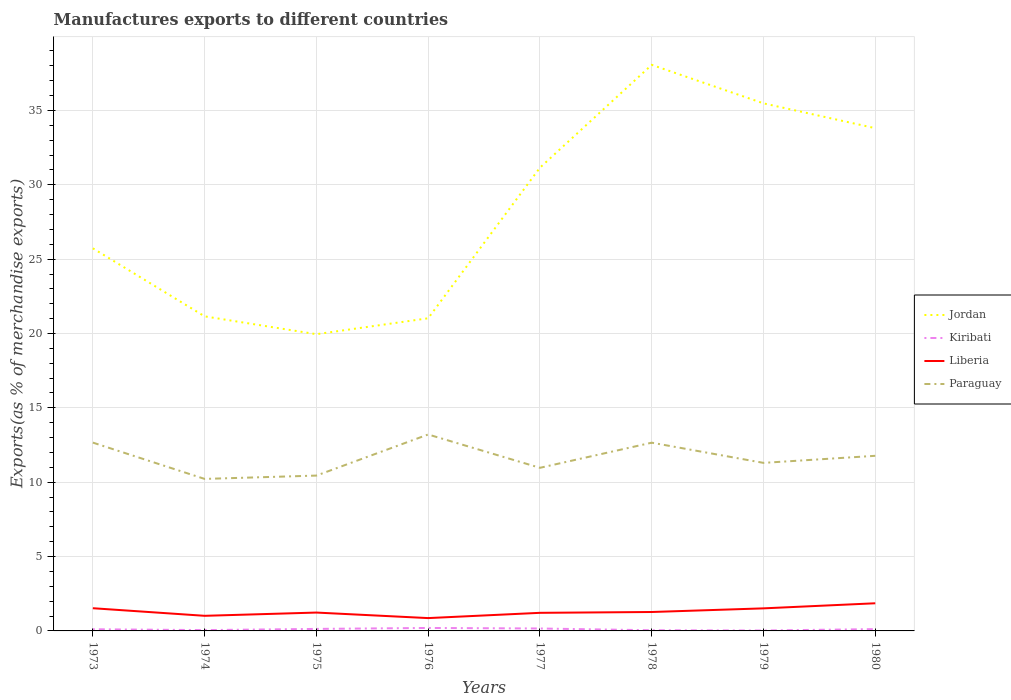How many different coloured lines are there?
Your response must be concise. 4. Across all years, what is the maximum percentage of exports to different countries in Paraguay?
Make the answer very short. 10.22. In which year was the percentage of exports to different countries in Kiribati maximum?
Offer a very short reply. 1979. What is the total percentage of exports to different countries in Jordan in the graph?
Provide a short and direct response. -11.2. What is the difference between the highest and the second highest percentage of exports to different countries in Paraguay?
Offer a terse response. 2.99. Is the percentage of exports to different countries in Kiribati strictly greater than the percentage of exports to different countries in Jordan over the years?
Your response must be concise. Yes. What is the difference between two consecutive major ticks on the Y-axis?
Provide a succinct answer. 5. How many legend labels are there?
Provide a succinct answer. 4. How are the legend labels stacked?
Give a very brief answer. Vertical. What is the title of the graph?
Provide a succinct answer. Manufactures exports to different countries. What is the label or title of the Y-axis?
Your response must be concise. Exports(as % of merchandise exports). What is the Exports(as % of merchandise exports) of Jordan in 1973?
Give a very brief answer. 25.73. What is the Exports(as % of merchandise exports) of Kiribati in 1973?
Your answer should be very brief. 0.11. What is the Exports(as % of merchandise exports) in Liberia in 1973?
Give a very brief answer. 1.53. What is the Exports(as % of merchandise exports) in Paraguay in 1973?
Your answer should be compact. 12.66. What is the Exports(as % of merchandise exports) in Jordan in 1974?
Ensure brevity in your answer.  21.15. What is the Exports(as % of merchandise exports) in Kiribati in 1974?
Ensure brevity in your answer.  0.06. What is the Exports(as % of merchandise exports) in Liberia in 1974?
Ensure brevity in your answer.  1.02. What is the Exports(as % of merchandise exports) of Paraguay in 1974?
Your response must be concise. 10.22. What is the Exports(as % of merchandise exports) of Jordan in 1975?
Your answer should be compact. 19.95. What is the Exports(as % of merchandise exports) in Kiribati in 1975?
Offer a very short reply. 0.14. What is the Exports(as % of merchandise exports) in Liberia in 1975?
Give a very brief answer. 1.23. What is the Exports(as % of merchandise exports) in Paraguay in 1975?
Give a very brief answer. 10.45. What is the Exports(as % of merchandise exports) in Jordan in 1976?
Keep it short and to the point. 21.02. What is the Exports(as % of merchandise exports) in Kiribati in 1976?
Provide a short and direct response. 0.2. What is the Exports(as % of merchandise exports) of Liberia in 1976?
Your response must be concise. 0.86. What is the Exports(as % of merchandise exports) of Paraguay in 1976?
Your answer should be compact. 13.21. What is the Exports(as % of merchandise exports) in Jordan in 1977?
Your answer should be very brief. 31.15. What is the Exports(as % of merchandise exports) of Kiribati in 1977?
Provide a short and direct response. 0.16. What is the Exports(as % of merchandise exports) in Liberia in 1977?
Keep it short and to the point. 1.22. What is the Exports(as % of merchandise exports) in Paraguay in 1977?
Your answer should be compact. 10.97. What is the Exports(as % of merchandise exports) of Jordan in 1978?
Give a very brief answer. 38.06. What is the Exports(as % of merchandise exports) in Kiribati in 1978?
Make the answer very short. 0.05. What is the Exports(as % of merchandise exports) in Liberia in 1978?
Make the answer very short. 1.27. What is the Exports(as % of merchandise exports) in Paraguay in 1978?
Make the answer very short. 12.66. What is the Exports(as % of merchandise exports) in Jordan in 1979?
Your answer should be compact. 35.47. What is the Exports(as % of merchandise exports) in Kiribati in 1979?
Your answer should be very brief. 0.03. What is the Exports(as % of merchandise exports) of Liberia in 1979?
Offer a very short reply. 1.52. What is the Exports(as % of merchandise exports) of Paraguay in 1979?
Give a very brief answer. 11.3. What is the Exports(as % of merchandise exports) in Jordan in 1980?
Your answer should be compact. 33.81. What is the Exports(as % of merchandise exports) of Kiribati in 1980?
Your answer should be very brief. 0.12. What is the Exports(as % of merchandise exports) of Liberia in 1980?
Your answer should be compact. 1.86. What is the Exports(as % of merchandise exports) of Paraguay in 1980?
Provide a short and direct response. 11.77. Across all years, what is the maximum Exports(as % of merchandise exports) of Jordan?
Your answer should be compact. 38.06. Across all years, what is the maximum Exports(as % of merchandise exports) of Kiribati?
Provide a succinct answer. 0.2. Across all years, what is the maximum Exports(as % of merchandise exports) of Liberia?
Your answer should be compact. 1.86. Across all years, what is the maximum Exports(as % of merchandise exports) of Paraguay?
Give a very brief answer. 13.21. Across all years, what is the minimum Exports(as % of merchandise exports) in Jordan?
Your response must be concise. 19.95. Across all years, what is the minimum Exports(as % of merchandise exports) in Kiribati?
Give a very brief answer. 0.03. Across all years, what is the minimum Exports(as % of merchandise exports) of Liberia?
Make the answer very short. 0.86. Across all years, what is the minimum Exports(as % of merchandise exports) in Paraguay?
Your answer should be compact. 10.22. What is the total Exports(as % of merchandise exports) of Jordan in the graph?
Provide a succinct answer. 226.35. What is the total Exports(as % of merchandise exports) in Kiribati in the graph?
Provide a succinct answer. 0.86. What is the total Exports(as % of merchandise exports) of Liberia in the graph?
Give a very brief answer. 10.51. What is the total Exports(as % of merchandise exports) in Paraguay in the graph?
Offer a very short reply. 93.24. What is the difference between the Exports(as % of merchandise exports) of Jordan in 1973 and that in 1974?
Your answer should be very brief. 4.58. What is the difference between the Exports(as % of merchandise exports) in Kiribati in 1973 and that in 1974?
Make the answer very short. 0.06. What is the difference between the Exports(as % of merchandise exports) in Liberia in 1973 and that in 1974?
Your answer should be very brief. 0.51. What is the difference between the Exports(as % of merchandise exports) in Paraguay in 1973 and that in 1974?
Your response must be concise. 2.44. What is the difference between the Exports(as % of merchandise exports) in Jordan in 1973 and that in 1975?
Give a very brief answer. 5.78. What is the difference between the Exports(as % of merchandise exports) in Kiribati in 1973 and that in 1975?
Ensure brevity in your answer.  -0.02. What is the difference between the Exports(as % of merchandise exports) of Liberia in 1973 and that in 1975?
Provide a short and direct response. 0.29. What is the difference between the Exports(as % of merchandise exports) of Paraguay in 1973 and that in 1975?
Offer a very short reply. 2.22. What is the difference between the Exports(as % of merchandise exports) in Jordan in 1973 and that in 1976?
Keep it short and to the point. 4.71. What is the difference between the Exports(as % of merchandise exports) of Kiribati in 1973 and that in 1976?
Offer a terse response. -0.09. What is the difference between the Exports(as % of merchandise exports) in Liberia in 1973 and that in 1976?
Provide a short and direct response. 0.66. What is the difference between the Exports(as % of merchandise exports) in Paraguay in 1973 and that in 1976?
Give a very brief answer. -0.55. What is the difference between the Exports(as % of merchandise exports) in Jordan in 1973 and that in 1977?
Provide a short and direct response. -5.42. What is the difference between the Exports(as % of merchandise exports) in Kiribati in 1973 and that in 1977?
Ensure brevity in your answer.  -0.05. What is the difference between the Exports(as % of merchandise exports) of Liberia in 1973 and that in 1977?
Your response must be concise. 0.31. What is the difference between the Exports(as % of merchandise exports) in Paraguay in 1973 and that in 1977?
Offer a terse response. 1.7. What is the difference between the Exports(as % of merchandise exports) in Jordan in 1973 and that in 1978?
Your response must be concise. -12.34. What is the difference between the Exports(as % of merchandise exports) in Kiribati in 1973 and that in 1978?
Offer a very short reply. 0.07. What is the difference between the Exports(as % of merchandise exports) of Liberia in 1973 and that in 1978?
Keep it short and to the point. 0.26. What is the difference between the Exports(as % of merchandise exports) in Paraguay in 1973 and that in 1978?
Your answer should be very brief. 0.01. What is the difference between the Exports(as % of merchandise exports) in Jordan in 1973 and that in 1979?
Ensure brevity in your answer.  -9.75. What is the difference between the Exports(as % of merchandise exports) in Kiribati in 1973 and that in 1979?
Give a very brief answer. 0.08. What is the difference between the Exports(as % of merchandise exports) of Liberia in 1973 and that in 1979?
Your response must be concise. 0.01. What is the difference between the Exports(as % of merchandise exports) of Paraguay in 1973 and that in 1979?
Provide a short and direct response. 1.36. What is the difference between the Exports(as % of merchandise exports) of Jordan in 1973 and that in 1980?
Provide a succinct answer. -8.08. What is the difference between the Exports(as % of merchandise exports) of Kiribati in 1973 and that in 1980?
Your answer should be very brief. -0.01. What is the difference between the Exports(as % of merchandise exports) of Liberia in 1973 and that in 1980?
Give a very brief answer. -0.33. What is the difference between the Exports(as % of merchandise exports) of Paraguay in 1973 and that in 1980?
Keep it short and to the point. 0.89. What is the difference between the Exports(as % of merchandise exports) in Kiribati in 1974 and that in 1975?
Provide a short and direct response. -0.08. What is the difference between the Exports(as % of merchandise exports) in Liberia in 1974 and that in 1975?
Your answer should be very brief. -0.22. What is the difference between the Exports(as % of merchandise exports) of Paraguay in 1974 and that in 1975?
Keep it short and to the point. -0.22. What is the difference between the Exports(as % of merchandise exports) in Jordan in 1974 and that in 1976?
Your answer should be compact. 0.13. What is the difference between the Exports(as % of merchandise exports) in Kiribati in 1974 and that in 1976?
Give a very brief answer. -0.14. What is the difference between the Exports(as % of merchandise exports) of Liberia in 1974 and that in 1976?
Your answer should be compact. 0.15. What is the difference between the Exports(as % of merchandise exports) of Paraguay in 1974 and that in 1976?
Your answer should be compact. -2.99. What is the difference between the Exports(as % of merchandise exports) in Jordan in 1974 and that in 1977?
Offer a very short reply. -10. What is the difference between the Exports(as % of merchandise exports) in Kiribati in 1974 and that in 1977?
Your answer should be very brief. -0.11. What is the difference between the Exports(as % of merchandise exports) in Liberia in 1974 and that in 1977?
Your response must be concise. -0.2. What is the difference between the Exports(as % of merchandise exports) of Paraguay in 1974 and that in 1977?
Make the answer very short. -0.75. What is the difference between the Exports(as % of merchandise exports) in Jordan in 1974 and that in 1978?
Keep it short and to the point. -16.91. What is the difference between the Exports(as % of merchandise exports) of Kiribati in 1974 and that in 1978?
Offer a very short reply. 0.01. What is the difference between the Exports(as % of merchandise exports) of Liberia in 1974 and that in 1978?
Make the answer very short. -0.26. What is the difference between the Exports(as % of merchandise exports) of Paraguay in 1974 and that in 1978?
Your answer should be very brief. -2.44. What is the difference between the Exports(as % of merchandise exports) in Jordan in 1974 and that in 1979?
Provide a succinct answer. -14.32. What is the difference between the Exports(as % of merchandise exports) in Kiribati in 1974 and that in 1979?
Provide a succinct answer. 0.03. What is the difference between the Exports(as % of merchandise exports) of Liberia in 1974 and that in 1979?
Give a very brief answer. -0.5. What is the difference between the Exports(as % of merchandise exports) of Paraguay in 1974 and that in 1979?
Your answer should be compact. -1.08. What is the difference between the Exports(as % of merchandise exports) of Jordan in 1974 and that in 1980?
Provide a short and direct response. -12.65. What is the difference between the Exports(as % of merchandise exports) of Kiribati in 1974 and that in 1980?
Offer a very short reply. -0.07. What is the difference between the Exports(as % of merchandise exports) in Liberia in 1974 and that in 1980?
Your response must be concise. -0.84. What is the difference between the Exports(as % of merchandise exports) of Paraguay in 1974 and that in 1980?
Keep it short and to the point. -1.55. What is the difference between the Exports(as % of merchandise exports) of Jordan in 1975 and that in 1976?
Offer a very short reply. -1.07. What is the difference between the Exports(as % of merchandise exports) of Kiribati in 1975 and that in 1976?
Offer a terse response. -0.06. What is the difference between the Exports(as % of merchandise exports) in Liberia in 1975 and that in 1976?
Make the answer very short. 0.37. What is the difference between the Exports(as % of merchandise exports) of Paraguay in 1975 and that in 1976?
Provide a succinct answer. -2.76. What is the difference between the Exports(as % of merchandise exports) of Jordan in 1975 and that in 1977?
Make the answer very short. -11.2. What is the difference between the Exports(as % of merchandise exports) in Kiribati in 1975 and that in 1977?
Make the answer very short. -0.03. What is the difference between the Exports(as % of merchandise exports) in Liberia in 1975 and that in 1977?
Offer a terse response. 0.02. What is the difference between the Exports(as % of merchandise exports) of Paraguay in 1975 and that in 1977?
Keep it short and to the point. -0.52. What is the difference between the Exports(as % of merchandise exports) in Jordan in 1975 and that in 1978?
Offer a very short reply. -18.11. What is the difference between the Exports(as % of merchandise exports) of Kiribati in 1975 and that in 1978?
Provide a short and direct response. 0.09. What is the difference between the Exports(as % of merchandise exports) of Liberia in 1975 and that in 1978?
Your answer should be very brief. -0.04. What is the difference between the Exports(as % of merchandise exports) of Paraguay in 1975 and that in 1978?
Give a very brief answer. -2.21. What is the difference between the Exports(as % of merchandise exports) in Jordan in 1975 and that in 1979?
Provide a short and direct response. -15.52. What is the difference between the Exports(as % of merchandise exports) of Kiribati in 1975 and that in 1979?
Provide a short and direct response. 0.11. What is the difference between the Exports(as % of merchandise exports) of Liberia in 1975 and that in 1979?
Your answer should be compact. -0.28. What is the difference between the Exports(as % of merchandise exports) in Paraguay in 1975 and that in 1979?
Make the answer very short. -0.85. What is the difference between the Exports(as % of merchandise exports) of Jordan in 1975 and that in 1980?
Offer a terse response. -13.85. What is the difference between the Exports(as % of merchandise exports) of Kiribati in 1975 and that in 1980?
Offer a very short reply. 0.01. What is the difference between the Exports(as % of merchandise exports) of Liberia in 1975 and that in 1980?
Offer a terse response. -0.62. What is the difference between the Exports(as % of merchandise exports) in Paraguay in 1975 and that in 1980?
Provide a succinct answer. -1.33. What is the difference between the Exports(as % of merchandise exports) in Jordan in 1976 and that in 1977?
Offer a very short reply. -10.13. What is the difference between the Exports(as % of merchandise exports) in Kiribati in 1976 and that in 1977?
Make the answer very short. 0.04. What is the difference between the Exports(as % of merchandise exports) of Liberia in 1976 and that in 1977?
Offer a terse response. -0.35. What is the difference between the Exports(as % of merchandise exports) in Paraguay in 1976 and that in 1977?
Your answer should be very brief. 2.24. What is the difference between the Exports(as % of merchandise exports) in Jordan in 1976 and that in 1978?
Provide a succinct answer. -17.04. What is the difference between the Exports(as % of merchandise exports) of Kiribati in 1976 and that in 1978?
Give a very brief answer. 0.15. What is the difference between the Exports(as % of merchandise exports) in Liberia in 1976 and that in 1978?
Provide a short and direct response. -0.41. What is the difference between the Exports(as % of merchandise exports) of Paraguay in 1976 and that in 1978?
Offer a very short reply. 0.55. What is the difference between the Exports(as % of merchandise exports) of Jordan in 1976 and that in 1979?
Provide a succinct answer. -14.45. What is the difference between the Exports(as % of merchandise exports) in Kiribati in 1976 and that in 1979?
Your answer should be compact. 0.17. What is the difference between the Exports(as % of merchandise exports) in Liberia in 1976 and that in 1979?
Ensure brevity in your answer.  -0.65. What is the difference between the Exports(as % of merchandise exports) of Paraguay in 1976 and that in 1979?
Your answer should be very brief. 1.91. What is the difference between the Exports(as % of merchandise exports) in Jordan in 1976 and that in 1980?
Provide a short and direct response. -12.78. What is the difference between the Exports(as % of merchandise exports) of Kiribati in 1976 and that in 1980?
Offer a terse response. 0.08. What is the difference between the Exports(as % of merchandise exports) in Liberia in 1976 and that in 1980?
Make the answer very short. -1. What is the difference between the Exports(as % of merchandise exports) in Paraguay in 1976 and that in 1980?
Make the answer very short. 1.43. What is the difference between the Exports(as % of merchandise exports) in Jordan in 1977 and that in 1978?
Keep it short and to the point. -6.91. What is the difference between the Exports(as % of merchandise exports) in Kiribati in 1977 and that in 1978?
Your response must be concise. 0.12. What is the difference between the Exports(as % of merchandise exports) in Liberia in 1977 and that in 1978?
Your answer should be compact. -0.06. What is the difference between the Exports(as % of merchandise exports) of Paraguay in 1977 and that in 1978?
Provide a short and direct response. -1.69. What is the difference between the Exports(as % of merchandise exports) of Jordan in 1977 and that in 1979?
Make the answer very short. -4.33. What is the difference between the Exports(as % of merchandise exports) in Kiribati in 1977 and that in 1979?
Offer a terse response. 0.14. What is the difference between the Exports(as % of merchandise exports) in Liberia in 1977 and that in 1979?
Your answer should be compact. -0.3. What is the difference between the Exports(as % of merchandise exports) in Paraguay in 1977 and that in 1979?
Your answer should be compact. -0.33. What is the difference between the Exports(as % of merchandise exports) in Jordan in 1977 and that in 1980?
Offer a terse response. -2.66. What is the difference between the Exports(as % of merchandise exports) of Kiribati in 1977 and that in 1980?
Provide a short and direct response. 0.04. What is the difference between the Exports(as % of merchandise exports) in Liberia in 1977 and that in 1980?
Provide a succinct answer. -0.64. What is the difference between the Exports(as % of merchandise exports) in Paraguay in 1977 and that in 1980?
Offer a very short reply. -0.81. What is the difference between the Exports(as % of merchandise exports) in Jordan in 1978 and that in 1979?
Ensure brevity in your answer.  2.59. What is the difference between the Exports(as % of merchandise exports) of Kiribati in 1978 and that in 1979?
Offer a terse response. 0.02. What is the difference between the Exports(as % of merchandise exports) in Liberia in 1978 and that in 1979?
Your answer should be compact. -0.25. What is the difference between the Exports(as % of merchandise exports) of Paraguay in 1978 and that in 1979?
Your answer should be compact. 1.36. What is the difference between the Exports(as % of merchandise exports) in Jordan in 1978 and that in 1980?
Ensure brevity in your answer.  4.26. What is the difference between the Exports(as % of merchandise exports) of Kiribati in 1978 and that in 1980?
Keep it short and to the point. -0.08. What is the difference between the Exports(as % of merchandise exports) in Liberia in 1978 and that in 1980?
Ensure brevity in your answer.  -0.59. What is the difference between the Exports(as % of merchandise exports) of Paraguay in 1978 and that in 1980?
Your answer should be compact. 0.88. What is the difference between the Exports(as % of merchandise exports) in Jordan in 1979 and that in 1980?
Provide a succinct answer. 1.67. What is the difference between the Exports(as % of merchandise exports) of Kiribati in 1979 and that in 1980?
Your response must be concise. -0.09. What is the difference between the Exports(as % of merchandise exports) in Liberia in 1979 and that in 1980?
Give a very brief answer. -0.34. What is the difference between the Exports(as % of merchandise exports) of Paraguay in 1979 and that in 1980?
Your answer should be compact. -0.47. What is the difference between the Exports(as % of merchandise exports) in Jordan in 1973 and the Exports(as % of merchandise exports) in Kiribati in 1974?
Ensure brevity in your answer.  25.67. What is the difference between the Exports(as % of merchandise exports) of Jordan in 1973 and the Exports(as % of merchandise exports) of Liberia in 1974?
Keep it short and to the point. 24.71. What is the difference between the Exports(as % of merchandise exports) of Jordan in 1973 and the Exports(as % of merchandise exports) of Paraguay in 1974?
Offer a very short reply. 15.51. What is the difference between the Exports(as % of merchandise exports) in Kiribati in 1973 and the Exports(as % of merchandise exports) in Liberia in 1974?
Provide a short and direct response. -0.9. What is the difference between the Exports(as % of merchandise exports) in Kiribati in 1973 and the Exports(as % of merchandise exports) in Paraguay in 1974?
Offer a very short reply. -10.11. What is the difference between the Exports(as % of merchandise exports) of Liberia in 1973 and the Exports(as % of merchandise exports) of Paraguay in 1974?
Ensure brevity in your answer.  -8.69. What is the difference between the Exports(as % of merchandise exports) of Jordan in 1973 and the Exports(as % of merchandise exports) of Kiribati in 1975?
Your response must be concise. 25.59. What is the difference between the Exports(as % of merchandise exports) in Jordan in 1973 and the Exports(as % of merchandise exports) in Liberia in 1975?
Give a very brief answer. 24.49. What is the difference between the Exports(as % of merchandise exports) of Jordan in 1973 and the Exports(as % of merchandise exports) of Paraguay in 1975?
Provide a short and direct response. 15.28. What is the difference between the Exports(as % of merchandise exports) in Kiribati in 1973 and the Exports(as % of merchandise exports) in Liberia in 1975?
Provide a short and direct response. -1.12. What is the difference between the Exports(as % of merchandise exports) in Kiribati in 1973 and the Exports(as % of merchandise exports) in Paraguay in 1975?
Your response must be concise. -10.33. What is the difference between the Exports(as % of merchandise exports) in Liberia in 1973 and the Exports(as % of merchandise exports) in Paraguay in 1975?
Ensure brevity in your answer.  -8.92. What is the difference between the Exports(as % of merchandise exports) in Jordan in 1973 and the Exports(as % of merchandise exports) in Kiribati in 1976?
Your response must be concise. 25.53. What is the difference between the Exports(as % of merchandise exports) of Jordan in 1973 and the Exports(as % of merchandise exports) of Liberia in 1976?
Make the answer very short. 24.87. What is the difference between the Exports(as % of merchandise exports) of Jordan in 1973 and the Exports(as % of merchandise exports) of Paraguay in 1976?
Provide a succinct answer. 12.52. What is the difference between the Exports(as % of merchandise exports) of Kiribati in 1973 and the Exports(as % of merchandise exports) of Liberia in 1976?
Keep it short and to the point. -0.75. What is the difference between the Exports(as % of merchandise exports) in Kiribati in 1973 and the Exports(as % of merchandise exports) in Paraguay in 1976?
Provide a short and direct response. -13.1. What is the difference between the Exports(as % of merchandise exports) in Liberia in 1973 and the Exports(as % of merchandise exports) in Paraguay in 1976?
Keep it short and to the point. -11.68. What is the difference between the Exports(as % of merchandise exports) of Jordan in 1973 and the Exports(as % of merchandise exports) of Kiribati in 1977?
Offer a terse response. 25.57. What is the difference between the Exports(as % of merchandise exports) of Jordan in 1973 and the Exports(as % of merchandise exports) of Liberia in 1977?
Keep it short and to the point. 24.51. What is the difference between the Exports(as % of merchandise exports) in Jordan in 1973 and the Exports(as % of merchandise exports) in Paraguay in 1977?
Give a very brief answer. 14.76. What is the difference between the Exports(as % of merchandise exports) of Kiribati in 1973 and the Exports(as % of merchandise exports) of Liberia in 1977?
Your answer should be compact. -1.1. What is the difference between the Exports(as % of merchandise exports) of Kiribati in 1973 and the Exports(as % of merchandise exports) of Paraguay in 1977?
Provide a succinct answer. -10.86. What is the difference between the Exports(as % of merchandise exports) in Liberia in 1973 and the Exports(as % of merchandise exports) in Paraguay in 1977?
Ensure brevity in your answer.  -9.44. What is the difference between the Exports(as % of merchandise exports) in Jordan in 1973 and the Exports(as % of merchandise exports) in Kiribati in 1978?
Offer a very short reply. 25.68. What is the difference between the Exports(as % of merchandise exports) of Jordan in 1973 and the Exports(as % of merchandise exports) of Liberia in 1978?
Give a very brief answer. 24.46. What is the difference between the Exports(as % of merchandise exports) of Jordan in 1973 and the Exports(as % of merchandise exports) of Paraguay in 1978?
Give a very brief answer. 13.07. What is the difference between the Exports(as % of merchandise exports) in Kiribati in 1973 and the Exports(as % of merchandise exports) in Liberia in 1978?
Your answer should be compact. -1.16. What is the difference between the Exports(as % of merchandise exports) of Kiribati in 1973 and the Exports(as % of merchandise exports) of Paraguay in 1978?
Your response must be concise. -12.55. What is the difference between the Exports(as % of merchandise exports) in Liberia in 1973 and the Exports(as % of merchandise exports) in Paraguay in 1978?
Your answer should be very brief. -11.13. What is the difference between the Exports(as % of merchandise exports) of Jordan in 1973 and the Exports(as % of merchandise exports) of Kiribati in 1979?
Offer a very short reply. 25.7. What is the difference between the Exports(as % of merchandise exports) of Jordan in 1973 and the Exports(as % of merchandise exports) of Liberia in 1979?
Your answer should be very brief. 24.21. What is the difference between the Exports(as % of merchandise exports) of Jordan in 1973 and the Exports(as % of merchandise exports) of Paraguay in 1979?
Give a very brief answer. 14.43. What is the difference between the Exports(as % of merchandise exports) of Kiribati in 1973 and the Exports(as % of merchandise exports) of Liberia in 1979?
Provide a succinct answer. -1.41. What is the difference between the Exports(as % of merchandise exports) of Kiribati in 1973 and the Exports(as % of merchandise exports) of Paraguay in 1979?
Keep it short and to the point. -11.19. What is the difference between the Exports(as % of merchandise exports) of Liberia in 1973 and the Exports(as % of merchandise exports) of Paraguay in 1979?
Your answer should be compact. -9.77. What is the difference between the Exports(as % of merchandise exports) in Jordan in 1973 and the Exports(as % of merchandise exports) in Kiribati in 1980?
Provide a succinct answer. 25.61. What is the difference between the Exports(as % of merchandise exports) in Jordan in 1973 and the Exports(as % of merchandise exports) in Liberia in 1980?
Make the answer very short. 23.87. What is the difference between the Exports(as % of merchandise exports) of Jordan in 1973 and the Exports(as % of merchandise exports) of Paraguay in 1980?
Offer a terse response. 13.95. What is the difference between the Exports(as % of merchandise exports) of Kiribati in 1973 and the Exports(as % of merchandise exports) of Liberia in 1980?
Your answer should be very brief. -1.75. What is the difference between the Exports(as % of merchandise exports) in Kiribati in 1973 and the Exports(as % of merchandise exports) in Paraguay in 1980?
Offer a terse response. -11.66. What is the difference between the Exports(as % of merchandise exports) in Liberia in 1973 and the Exports(as % of merchandise exports) in Paraguay in 1980?
Your answer should be very brief. -10.25. What is the difference between the Exports(as % of merchandise exports) of Jordan in 1974 and the Exports(as % of merchandise exports) of Kiribati in 1975?
Offer a terse response. 21.02. What is the difference between the Exports(as % of merchandise exports) of Jordan in 1974 and the Exports(as % of merchandise exports) of Liberia in 1975?
Offer a very short reply. 19.92. What is the difference between the Exports(as % of merchandise exports) of Jordan in 1974 and the Exports(as % of merchandise exports) of Paraguay in 1975?
Ensure brevity in your answer.  10.71. What is the difference between the Exports(as % of merchandise exports) in Kiribati in 1974 and the Exports(as % of merchandise exports) in Liberia in 1975?
Ensure brevity in your answer.  -1.18. What is the difference between the Exports(as % of merchandise exports) in Kiribati in 1974 and the Exports(as % of merchandise exports) in Paraguay in 1975?
Offer a terse response. -10.39. What is the difference between the Exports(as % of merchandise exports) in Liberia in 1974 and the Exports(as % of merchandise exports) in Paraguay in 1975?
Provide a succinct answer. -9.43. What is the difference between the Exports(as % of merchandise exports) of Jordan in 1974 and the Exports(as % of merchandise exports) of Kiribati in 1976?
Your answer should be very brief. 20.95. What is the difference between the Exports(as % of merchandise exports) in Jordan in 1974 and the Exports(as % of merchandise exports) in Liberia in 1976?
Your answer should be very brief. 20.29. What is the difference between the Exports(as % of merchandise exports) in Jordan in 1974 and the Exports(as % of merchandise exports) in Paraguay in 1976?
Your answer should be compact. 7.94. What is the difference between the Exports(as % of merchandise exports) of Kiribati in 1974 and the Exports(as % of merchandise exports) of Liberia in 1976?
Provide a succinct answer. -0.81. What is the difference between the Exports(as % of merchandise exports) in Kiribati in 1974 and the Exports(as % of merchandise exports) in Paraguay in 1976?
Give a very brief answer. -13.15. What is the difference between the Exports(as % of merchandise exports) of Liberia in 1974 and the Exports(as % of merchandise exports) of Paraguay in 1976?
Offer a very short reply. -12.19. What is the difference between the Exports(as % of merchandise exports) in Jordan in 1974 and the Exports(as % of merchandise exports) in Kiribati in 1977?
Provide a succinct answer. 20.99. What is the difference between the Exports(as % of merchandise exports) of Jordan in 1974 and the Exports(as % of merchandise exports) of Liberia in 1977?
Offer a very short reply. 19.94. What is the difference between the Exports(as % of merchandise exports) of Jordan in 1974 and the Exports(as % of merchandise exports) of Paraguay in 1977?
Keep it short and to the point. 10.19. What is the difference between the Exports(as % of merchandise exports) of Kiribati in 1974 and the Exports(as % of merchandise exports) of Liberia in 1977?
Provide a short and direct response. -1.16. What is the difference between the Exports(as % of merchandise exports) of Kiribati in 1974 and the Exports(as % of merchandise exports) of Paraguay in 1977?
Your answer should be very brief. -10.91. What is the difference between the Exports(as % of merchandise exports) of Liberia in 1974 and the Exports(as % of merchandise exports) of Paraguay in 1977?
Your answer should be very brief. -9.95. What is the difference between the Exports(as % of merchandise exports) of Jordan in 1974 and the Exports(as % of merchandise exports) of Kiribati in 1978?
Offer a very short reply. 21.11. What is the difference between the Exports(as % of merchandise exports) of Jordan in 1974 and the Exports(as % of merchandise exports) of Liberia in 1978?
Give a very brief answer. 19.88. What is the difference between the Exports(as % of merchandise exports) of Jordan in 1974 and the Exports(as % of merchandise exports) of Paraguay in 1978?
Offer a terse response. 8.5. What is the difference between the Exports(as % of merchandise exports) of Kiribati in 1974 and the Exports(as % of merchandise exports) of Liberia in 1978?
Your answer should be very brief. -1.22. What is the difference between the Exports(as % of merchandise exports) in Kiribati in 1974 and the Exports(as % of merchandise exports) in Paraguay in 1978?
Provide a short and direct response. -12.6. What is the difference between the Exports(as % of merchandise exports) of Liberia in 1974 and the Exports(as % of merchandise exports) of Paraguay in 1978?
Your answer should be very brief. -11.64. What is the difference between the Exports(as % of merchandise exports) in Jordan in 1974 and the Exports(as % of merchandise exports) in Kiribati in 1979?
Offer a very short reply. 21.13. What is the difference between the Exports(as % of merchandise exports) of Jordan in 1974 and the Exports(as % of merchandise exports) of Liberia in 1979?
Ensure brevity in your answer.  19.64. What is the difference between the Exports(as % of merchandise exports) of Jordan in 1974 and the Exports(as % of merchandise exports) of Paraguay in 1979?
Offer a very short reply. 9.85. What is the difference between the Exports(as % of merchandise exports) of Kiribati in 1974 and the Exports(as % of merchandise exports) of Liberia in 1979?
Ensure brevity in your answer.  -1.46. What is the difference between the Exports(as % of merchandise exports) in Kiribati in 1974 and the Exports(as % of merchandise exports) in Paraguay in 1979?
Offer a terse response. -11.24. What is the difference between the Exports(as % of merchandise exports) of Liberia in 1974 and the Exports(as % of merchandise exports) of Paraguay in 1979?
Your answer should be compact. -10.28. What is the difference between the Exports(as % of merchandise exports) of Jordan in 1974 and the Exports(as % of merchandise exports) of Kiribati in 1980?
Your answer should be compact. 21.03. What is the difference between the Exports(as % of merchandise exports) in Jordan in 1974 and the Exports(as % of merchandise exports) in Liberia in 1980?
Ensure brevity in your answer.  19.29. What is the difference between the Exports(as % of merchandise exports) of Jordan in 1974 and the Exports(as % of merchandise exports) of Paraguay in 1980?
Your response must be concise. 9.38. What is the difference between the Exports(as % of merchandise exports) of Kiribati in 1974 and the Exports(as % of merchandise exports) of Liberia in 1980?
Ensure brevity in your answer.  -1.8. What is the difference between the Exports(as % of merchandise exports) in Kiribati in 1974 and the Exports(as % of merchandise exports) in Paraguay in 1980?
Your answer should be compact. -11.72. What is the difference between the Exports(as % of merchandise exports) of Liberia in 1974 and the Exports(as % of merchandise exports) of Paraguay in 1980?
Provide a succinct answer. -10.76. What is the difference between the Exports(as % of merchandise exports) of Jordan in 1975 and the Exports(as % of merchandise exports) of Kiribati in 1976?
Provide a succinct answer. 19.75. What is the difference between the Exports(as % of merchandise exports) in Jordan in 1975 and the Exports(as % of merchandise exports) in Liberia in 1976?
Offer a terse response. 19.09. What is the difference between the Exports(as % of merchandise exports) of Jordan in 1975 and the Exports(as % of merchandise exports) of Paraguay in 1976?
Your response must be concise. 6.74. What is the difference between the Exports(as % of merchandise exports) of Kiribati in 1975 and the Exports(as % of merchandise exports) of Liberia in 1976?
Your answer should be very brief. -0.73. What is the difference between the Exports(as % of merchandise exports) in Kiribati in 1975 and the Exports(as % of merchandise exports) in Paraguay in 1976?
Your answer should be compact. -13.07. What is the difference between the Exports(as % of merchandise exports) in Liberia in 1975 and the Exports(as % of merchandise exports) in Paraguay in 1976?
Your answer should be very brief. -11.97. What is the difference between the Exports(as % of merchandise exports) in Jordan in 1975 and the Exports(as % of merchandise exports) in Kiribati in 1977?
Your answer should be very brief. 19.79. What is the difference between the Exports(as % of merchandise exports) of Jordan in 1975 and the Exports(as % of merchandise exports) of Liberia in 1977?
Your answer should be very brief. 18.74. What is the difference between the Exports(as % of merchandise exports) in Jordan in 1975 and the Exports(as % of merchandise exports) in Paraguay in 1977?
Keep it short and to the point. 8.99. What is the difference between the Exports(as % of merchandise exports) in Kiribati in 1975 and the Exports(as % of merchandise exports) in Liberia in 1977?
Provide a succinct answer. -1.08. What is the difference between the Exports(as % of merchandise exports) in Kiribati in 1975 and the Exports(as % of merchandise exports) in Paraguay in 1977?
Offer a very short reply. -10.83. What is the difference between the Exports(as % of merchandise exports) in Liberia in 1975 and the Exports(as % of merchandise exports) in Paraguay in 1977?
Provide a succinct answer. -9.73. What is the difference between the Exports(as % of merchandise exports) of Jordan in 1975 and the Exports(as % of merchandise exports) of Kiribati in 1978?
Provide a succinct answer. 19.91. What is the difference between the Exports(as % of merchandise exports) of Jordan in 1975 and the Exports(as % of merchandise exports) of Liberia in 1978?
Give a very brief answer. 18.68. What is the difference between the Exports(as % of merchandise exports) of Jordan in 1975 and the Exports(as % of merchandise exports) of Paraguay in 1978?
Your response must be concise. 7.3. What is the difference between the Exports(as % of merchandise exports) in Kiribati in 1975 and the Exports(as % of merchandise exports) in Liberia in 1978?
Provide a succinct answer. -1.14. What is the difference between the Exports(as % of merchandise exports) of Kiribati in 1975 and the Exports(as % of merchandise exports) of Paraguay in 1978?
Make the answer very short. -12.52. What is the difference between the Exports(as % of merchandise exports) in Liberia in 1975 and the Exports(as % of merchandise exports) in Paraguay in 1978?
Offer a very short reply. -11.42. What is the difference between the Exports(as % of merchandise exports) of Jordan in 1975 and the Exports(as % of merchandise exports) of Kiribati in 1979?
Provide a succinct answer. 19.93. What is the difference between the Exports(as % of merchandise exports) in Jordan in 1975 and the Exports(as % of merchandise exports) in Liberia in 1979?
Ensure brevity in your answer.  18.44. What is the difference between the Exports(as % of merchandise exports) in Jordan in 1975 and the Exports(as % of merchandise exports) in Paraguay in 1979?
Make the answer very short. 8.65. What is the difference between the Exports(as % of merchandise exports) of Kiribati in 1975 and the Exports(as % of merchandise exports) of Liberia in 1979?
Keep it short and to the point. -1.38. What is the difference between the Exports(as % of merchandise exports) in Kiribati in 1975 and the Exports(as % of merchandise exports) in Paraguay in 1979?
Give a very brief answer. -11.16. What is the difference between the Exports(as % of merchandise exports) in Liberia in 1975 and the Exports(as % of merchandise exports) in Paraguay in 1979?
Offer a very short reply. -10.07. What is the difference between the Exports(as % of merchandise exports) of Jordan in 1975 and the Exports(as % of merchandise exports) of Kiribati in 1980?
Your answer should be compact. 19.83. What is the difference between the Exports(as % of merchandise exports) of Jordan in 1975 and the Exports(as % of merchandise exports) of Liberia in 1980?
Your answer should be compact. 18.09. What is the difference between the Exports(as % of merchandise exports) of Jordan in 1975 and the Exports(as % of merchandise exports) of Paraguay in 1980?
Provide a short and direct response. 8.18. What is the difference between the Exports(as % of merchandise exports) in Kiribati in 1975 and the Exports(as % of merchandise exports) in Liberia in 1980?
Ensure brevity in your answer.  -1.72. What is the difference between the Exports(as % of merchandise exports) of Kiribati in 1975 and the Exports(as % of merchandise exports) of Paraguay in 1980?
Provide a succinct answer. -11.64. What is the difference between the Exports(as % of merchandise exports) of Liberia in 1975 and the Exports(as % of merchandise exports) of Paraguay in 1980?
Offer a terse response. -10.54. What is the difference between the Exports(as % of merchandise exports) in Jordan in 1976 and the Exports(as % of merchandise exports) in Kiribati in 1977?
Offer a very short reply. 20.86. What is the difference between the Exports(as % of merchandise exports) in Jordan in 1976 and the Exports(as % of merchandise exports) in Liberia in 1977?
Offer a terse response. 19.81. What is the difference between the Exports(as % of merchandise exports) of Jordan in 1976 and the Exports(as % of merchandise exports) of Paraguay in 1977?
Offer a terse response. 10.06. What is the difference between the Exports(as % of merchandise exports) in Kiribati in 1976 and the Exports(as % of merchandise exports) in Liberia in 1977?
Provide a succinct answer. -1.02. What is the difference between the Exports(as % of merchandise exports) in Kiribati in 1976 and the Exports(as % of merchandise exports) in Paraguay in 1977?
Offer a terse response. -10.77. What is the difference between the Exports(as % of merchandise exports) in Liberia in 1976 and the Exports(as % of merchandise exports) in Paraguay in 1977?
Your response must be concise. -10.1. What is the difference between the Exports(as % of merchandise exports) in Jordan in 1976 and the Exports(as % of merchandise exports) in Kiribati in 1978?
Keep it short and to the point. 20.98. What is the difference between the Exports(as % of merchandise exports) of Jordan in 1976 and the Exports(as % of merchandise exports) of Liberia in 1978?
Give a very brief answer. 19.75. What is the difference between the Exports(as % of merchandise exports) in Jordan in 1976 and the Exports(as % of merchandise exports) in Paraguay in 1978?
Ensure brevity in your answer.  8.37. What is the difference between the Exports(as % of merchandise exports) of Kiribati in 1976 and the Exports(as % of merchandise exports) of Liberia in 1978?
Provide a succinct answer. -1.07. What is the difference between the Exports(as % of merchandise exports) of Kiribati in 1976 and the Exports(as % of merchandise exports) of Paraguay in 1978?
Keep it short and to the point. -12.46. What is the difference between the Exports(as % of merchandise exports) in Liberia in 1976 and the Exports(as % of merchandise exports) in Paraguay in 1978?
Keep it short and to the point. -11.79. What is the difference between the Exports(as % of merchandise exports) of Jordan in 1976 and the Exports(as % of merchandise exports) of Kiribati in 1979?
Give a very brief answer. 21. What is the difference between the Exports(as % of merchandise exports) of Jordan in 1976 and the Exports(as % of merchandise exports) of Liberia in 1979?
Your response must be concise. 19.51. What is the difference between the Exports(as % of merchandise exports) of Jordan in 1976 and the Exports(as % of merchandise exports) of Paraguay in 1979?
Keep it short and to the point. 9.72. What is the difference between the Exports(as % of merchandise exports) in Kiribati in 1976 and the Exports(as % of merchandise exports) in Liberia in 1979?
Your answer should be compact. -1.32. What is the difference between the Exports(as % of merchandise exports) of Kiribati in 1976 and the Exports(as % of merchandise exports) of Paraguay in 1979?
Make the answer very short. -11.1. What is the difference between the Exports(as % of merchandise exports) of Liberia in 1976 and the Exports(as % of merchandise exports) of Paraguay in 1979?
Provide a succinct answer. -10.44. What is the difference between the Exports(as % of merchandise exports) in Jordan in 1976 and the Exports(as % of merchandise exports) in Kiribati in 1980?
Give a very brief answer. 20.9. What is the difference between the Exports(as % of merchandise exports) of Jordan in 1976 and the Exports(as % of merchandise exports) of Liberia in 1980?
Your answer should be very brief. 19.16. What is the difference between the Exports(as % of merchandise exports) in Jordan in 1976 and the Exports(as % of merchandise exports) in Paraguay in 1980?
Your answer should be compact. 9.25. What is the difference between the Exports(as % of merchandise exports) in Kiribati in 1976 and the Exports(as % of merchandise exports) in Liberia in 1980?
Your response must be concise. -1.66. What is the difference between the Exports(as % of merchandise exports) of Kiribati in 1976 and the Exports(as % of merchandise exports) of Paraguay in 1980?
Your answer should be compact. -11.58. What is the difference between the Exports(as % of merchandise exports) in Liberia in 1976 and the Exports(as % of merchandise exports) in Paraguay in 1980?
Your answer should be very brief. -10.91. What is the difference between the Exports(as % of merchandise exports) of Jordan in 1977 and the Exports(as % of merchandise exports) of Kiribati in 1978?
Your answer should be very brief. 31.1. What is the difference between the Exports(as % of merchandise exports) of Jordan in 1977 and the Exports(as % of merchandise exports) of Liberia in 1978?
Your answer should be compact. 29.88. What is the difference between the Exports(as % of merchandise exports) in Jordan in 1977 and the Exports(as % of merchandise exports) in Paraguay in 1978?
Ensure brevity in your answer.  18.49. What is the difference between the Exports(as % of merchandise exports) in Kiribati in 1977 and the Exports(as % of merchandise exports) in Liberia in 1978?
Offer a very short reply. -1.11. What is the difference between the Exports(as % of merchandise exports) in Kiribati in 1977 and the Exports(as % of merchandise exports) in Paraguay in 1978?
Provide a succinct answer. -12.49. What is the difference between the Exports(as % of merchandise exports) of Liberia in 1977 and the Exports(as % of merchandise exports) of Paraguay in 1978?
Your answer should be compact. -11.44. What is the difference between the Exports(as % of merchandise exports) of Jordan in 1977 and the Exports(as % of merchandise exports) of Kiribati in 1979?
Offer a very short reply. 31.12. What is the difference between the Exports(as % of merchandise exports) of Jordan in 1977 and the Exports(as % of merchandise exports) of Liberia in 1979?
Offer a very short reply. 29.63. What is the difference between the Exports(as % of merchandise exports) of Jordan in 1977 and the Exports(as % of merchandise exports) of Paraguay in 1979?
Provide a succinct answer. 19.85. What is the difference between the Exports(as % of merchandise exports) in Kiribati in 1977 and the Exports(as % of merchandise exports) in Liberia in 1979?
Provide a short and direct response. -1.35. What is the difference between the Exports(as % of merchandise exports) of Kiribati in 1977 and the Exports(as % of merchandise exports) of Paraguay in 1979?
Your answer should be compact. -11.14. What is the difference between the Exports(as % of merchandise exports) of Liberia in 1977 and the Exports(as % of merchandise exports) of Paraguay in 1979?
Make the answer very short. -10.08. What is the difference between the Exports(as % of merchandise exports) in Jordan in 1977 and the Exports(as % of merchandise exports) in Kiribati in 1980?
Provide a short and direct response. 31.03. What is the difference between the Exports(as % of merchandise exports) in Jordan in 1977 and the Exports(as % of merchandise exports) in Liberia in 1980?
Offer a very short reply. 29.29. What is the difference between the Exports(as % of merchandise exports) of Jordan in 1977 and the Exports(as % of merchandise exports) of Paraguay in 1980?
Your answer should be compact. 19.37. What is the difference between the Exports(as % of merchandise exports) of Kiribati in 1977 and the Exports(as % of merchandise exports) of Liberia in 1980?
Make the answer very short. -1.7. What is the difference between the Exports(as % of merchandise exports) in Kiribati in 1977 and the Exports(as % of merchandise exports) in Paraguay in 1980?
Your answer should be very brief. -11.61. What is the difference between the Exports(as % of merchandise exports) of Liberia in 1977 and the Exports(as % of merchandise exports) of Paraguay in 1980?
Make the answer very short. -10.56. What is the difference between the Exports(as % of merchandise exports) in Jordan in 1978 and the Exports(as % of merchandise exports) in Kiribati in 1979?
Provide a short and direct response. 38.04. What is the difference between the Exports(as % of merchandise exports) of Jordan in 1978 and the Exports(as % of merchandise exports) of Liberia in 1979?
Offer a very short reply. 36.55. What is the difference between the Exports(as % of merchandise exports) of Jordan in 1978 and the Exports(as % of merchandise exports) of Paraguay in 1979?
Make the answer very short. 26.76. What is the difference between the Exports(as % of merchandise exports) of Kiribati in 1978 and the Exports(as % of merchandise exports) of Liberia in 1979?
Ensure brevity in your answer.  -1.47. What is the difference between the Exports(as % of merchandise exports) of Kiribati in 1978 and the Exports(as % of merchandise exports) of Paraguay in 1979?
Your response must be concise. -11.25. What is the difference between the Exports(as % of merchandise exports) of Liberia in 1978 and the Exports(as % of merchandise exports) of Paraguay in 1979?
Offer a very short reply. -10.03. What is the difference between the Exports(as % of merchandise exports) in Jordan in 1978 and the Exports(as % of merchandise exports) in Kiribati in 1980?
Keep it short and to the point. 37.94. What is the difference between the Exports(as % of merchandise exports) in Jordan in 1978 and the Exports(as % of merchandise exports) in Liberia in 1980?
Ensure brevity in your answer.  36.2. What is the difference between the Exports(as % of merchandise exports) in Jordan in 1978 and the Exports(as % of merchandise exports) in Paraguay in 1980?
Give a very brief answer. 26.29. What is the difference between the Exports(as % of merchandise exports) in Kiribati in 1978 and the Exports(as % of merchandise exports) in Liberia in 1980?
Your answer should be very brief. -1.81. What is the difference between the Exports(as % of merchandise exports) of Kiribati in 1978 and the Exports(as % of merchandise exports) of Paraguay in 1980?
Ensure brevity in your answer.  -11.73. What is the difference between the Exports(as % of merchandise exports) of Liberia in 1978 and the Exports(as % of merchandise exports) of Paraguay in 1980?
Offer a very short reply. -10.5. What is the difference between the Exports(as % of merchandise exports) in Jordan in 1979 and the Exports(as % of merchandise exports) in Kiribati in 1980?
Give a very brief answer. 35.35. What is the difference between the Exports(as % of merchandise exports) of Jordan in 1979 and the Exports(as % of merchandise exports) of Liberia in 1980?
Your answer should be very brief. 33.62. What is the difference between the Exports(as % of merchandise exports) in Jordan in 1979 and the Exports(as % of merchandise exports) in Paraguay in 1980?
Provide a short and direct response. 23.7. What is the difference between the Exports(as % of merchandise exports) in Kiribati in 1979 and the Exports(as % of merchandise exports) in Liberia in 1980?
Offer a terse response. -1.83. What is the difference between the Exports(as % of merchandise exports) in Kiribati in 1979 and the Exports(as % of merchandise exports) in Paraguay in 1980?
Offer a very short reply. -11.75. What is the difference between the Exports(as % of merchandise exports) of Liberia in 1979 and the Exports(as % of merchandise exports) of Paraguay in 1980?
Offer a terse response. -10.26. What is the average Exports(as % of merchandise exports) of Jordan per year?
Give a very brief answer. 28.29. What is the average Exports(as % of merchandise exports) of Kiribati per year?
Provide a short and direct response. 0.11. What is the average Exports(as % of merchandise exports) of Liberia per year?
Make the answer very short. 1.31. What is the average Exports(as % of merchandise exports) in Paraguay per year?
Provide a succinct answer. 11.65. In the year 1973, what is the difference between the Exports(as % of merchandise exports) in Jordan and Exports(as % of merchandise exports) in Kiribati?
Make the answer very short. 25.62. In the year 1973, what is the difference between the Exports(as % of merchandise exports) in Jordan and Exports(as % of merchandise exports) in Liberia?
Make the answer very short. 24.2. In the year 1973, what is the difference between the Exports(as % of merchandise exports) in Jordan and Exports(as % of merchandise exports) in Paraguay?
Offer a terse response. 13.07. In the year 1973, what is the difference between the Exports(as % of merchandise exports) of Kiribati and Exports(as % of merchandise exports) of Liberia?
Your answer should be very brief. -1.41. In the year 1973, what is the difference between the Exports(as % of merchandise exports) of Kiribati and Exports(as % of merchandise exports) of Paraguay?
Your answer should be very brief. -12.55. In the year 1973, what is the difference between the Exports(as % of merchandise exports) in Liberia and Exports(as % of merchandise exports) in Paraguay?
Make the answer very short. -11.14. In the year 1974, what is the difference between the Exports(as % of merchandise exports) of Jordan and Exports(as % of merchandise exports) of Kiribati?
Provide a short and direct response. 21.1. In the year 1974, what is the difference between the Exports(as % of merchandise exports) in Jordan and Exports(as % of merchandise exports) in Liberia?
Your answer should be very brief. 20.14. In the year 1974, what is the difference between the Exports(as % of merchandise exports) of Jordan and Exports(as % of merchandise exports) of Paraguay?
Provide a short and direct response. 10.93. In the year 1974, what is the difference between the Exports(as % of merchandise exports) of Kiribati and Exports(as % of merchandise exports) of Liberia?
Your answer should be very brief. -0.96. In the year 1974, what is the difference between the Exports(as % of merchandise exports) of Kiribati and Exports(as % of merchandise exports) of Paraguay?
Offer a terse response. -10.17. In the year 1974, what is the difference between the Exports(as % of merchandise exports) of Liberia and Exports(as % of merchandise exports) of Paraguay?
Make the answer very short. -9.21. In the year 1975, what is the difference between the Exports(as % of merchandise exports) in Jordan and Exports(as % of merchandise exports) in Kiribati?
Your answer should be compact. 19.82. In the year 1975, what is the difference between the Exports(as % of merchandise exports) in Jordan and Exports(as % of merchandise exports) in Liberia?
Give a very brief answer. 18.72. In the year 1975, what is the difference between the Exports(as % of merchandise exports) of Jordan and Exports(as % of merchandise exports) of Paraguay?
Offer a terse response. 9.51. In the year 1975, what is the difference between the Exports(as % of merchandise exports) of Kiribati and Exports(as % of merchandise exports) of Liberia?
Ensure brevity in your answer.  -1.1. In the year 1975, what is the difference between the Exports(as % of merchandise exports) in Kiribati and Exports(as % of merchandise exports) in Paraguay?
Ensure brevity in your answer.  -10.31. In the year 1975, what is the difference between the Exports(as % of merchandise exports) of Liberia and Exports(as % of merchandise exports) of Paraguay?
Your answer should be very brief. -9.21. In the year 1976, what is the difference between the Exports(as % of merchandise exports) of Jordan and Exports(as % of merchandise exports) of Kiribati?
Your response must be concise. 20.82. In the year 1976, what is the difference between the Exports(as % of merchandise exports) in Jordan and Exports(as % of merchandise exports) in Liberia?
Make the answer very short. 20.16. In the year 1976, what is the difference between the Exports(as % of merchandise exports) of Jordan and Exports(as % of merchandise exports) of Paraguay?
Your response must be concise. 7.81. In the year 1976, what is the difference between the Exports(as % of merchandise exports) in Kiribati and Exports(as % of merchandise exports) in Liberia?
Offer a terse response. -0.66. In the year 1976, what is the difference between the Exports(as % of merchandise exports) of Kiribati and Exports(as % of merchandise exports) of Paraguay?
Make the answer very short. -13.01. In the year 1976, what is the difference between the Exports(as % of merchandise exports) of Liberia and Exports(as % of merchandise exports) of Paraguay?
Give a very brief answer. -12.35. In the year 1977, what is the difference between the Exports(as % of merchandise exports) of Jordan and Exports(as % of merchandise exports) of Kiribati?
Give a very brief answer. 30.99. In the year 1977, what is the difference between the Exports(as % of merchandise exports) of Jordan and Exports(as % of merchandise exports) of Liberia?
Provide a short and direct response. 29.93. In the year 1977, what is the difference between the Exports(as % of merchandise exports) of Jordan and Exports(as % of merchandise exports) of Paraguay?
Make the answer very short. 20.18. In the year 1977, what is the difference between the Exports(as % of merchandise exports) in Kiribati and Exports(as % of merchandise exports) in Liberia?
Your answer should be compact. -1.05. In the year 1977, what is the difference between the Exports(as % of merchandise exports) in Kiribati and Exports(as % of merchandise exports) in Paraguay?
Make the answer very short. -10.8. In the year 1977, what is the difference between the Exports(as % of merchandise exports) of Liberia and Exports(as % of merchandise exports) of Paraguay?
Keep it short and to the point. -9.75. In the year 1978, what is the difference between the Exports(as % of merchandise exports) of Jordan and Exports(as % of merchandise exports) of Kiribati?
Your answer should be compact. 38.02. In the year 1978, what is the difference between the Exports(as % of merchandise exports) in Jordan and Exports(as % of merchandise exports) in Liberia?
Keep it short and to the point. 36.79. In the year 1978, what is the difference between the Exports(as % of merchandise exports) in Jordan and Exports(as % of merchandise exports) in Paraguay?
Give a very brief answer. 25.41. In the year 1978, what is the difference between the Exports(as % of merchandise exports) in Kiribati and Exports(as % of merchandise exports) in Liberia?
Provide a short and direct response. -1.23. In the year 1978, what is the difference between the Exports(as % of merchandise exports) of Kiribati and Exports(as % of merchandise exports) of Paraguay?
Keep it short and to the point. -12.61. In the year 1978, what is the difference between the Exports(as % of merchandise exports) of Liberia and Exports(as % of merchandise exports) of Paraguay?
Make the answer very short. -11.39. In the year 1979, what is the difference between the Exports(as % of merchandise exports) in Jordan and Exports(as % of merchandise exports) in Kiribati?
Keep it short and to the point. 35.45. In the year 1979, what is the difference between the Exports(as % of merchandise exports) in Jordan and Exports(as % of merchandise exports) in Liberia?
Provide a short and direct response. 33.96. In the year 1979, what is the difference between the Exports(as % of merchandise exports) in Jordan and Exports(as % of merchandise exports) in Paraguay?
Make the answer very short. 24.17. In the year 1979, what is the difference between the Exports(as % of merchandise exports) in Kiribati and Exports(as % of merchandise exports) in Liberia?
Offer a very short reply. -1.49. In the year 1979, what is the difference between the Exports(as % of merchandise exports) of Kiribati and Exports(as % of merchandise exports) of Paraguay?
Offer a very short reply. -11.27. In the year 1979, what is the difference between the Exports(as % of merchandise exports) in Liberia and Exports(as % of merchandise exports) in Paraguay?
Your response must be concise. -9.78. In the year 1980, what is the difference between the Exports(as % of merchandise exports) of Jordan and Exports(as % of merchandise exports) of Kiribati?
Ensure brevity in your answer.  33.68. In the year 1980, what is the difference between the Exports(as % of merchandise exports) of Jordan and Exports(as % of merchandise exports) of Liberia?
Your response must be concise. 31.95. In the year 1980, what is the difference between the Exports(as % of merchandise exports) of Jordan and Exports(as % of merchandise exports) of Paraguay?
Provide a short and direct response. 22.03. In the year 1980, what is the difference between the Exports(as % of merchandise exports) in Kiribati and Exports(as % of merchandise exports) in Liberia?
Your response must be concise. -1.74. In the year 1980, what is the difference between the Exports(as % of merchandise exports) in Kiribati and Exports(as % of merchandise exports) in Paraguay?
Offer a very short reply. -11.65. In the year 1980, what is the difference between the Exports(as % of merchandise exports) of Liberia and Exports(as % of merchandise exports) of Paraguay?
Provide a succinct answer. -9.92. What is the ratio of the Exports(as % of merchandise exports) in Jordan in 1973 to that in 1974?
Offer a terse response. 1.22. What is the ratio of the Exports(as % of merchandise exports) of Kiribati in 1973 to that in 1974?
Keep it short and to the point. 2.01. What is the ratio of the Exports(as % of merchandise exports) in Liberia in 1973 to that in 1974?
Give a very brief answer. 1.5. What is the ratio of the Exports(as % of merchandise exports) of Paraguay in 1973 to that in 1974?
Ensure brevity in your answer.  1.24. What is the ratio of the Exports(as % of merchandise exports) in Jordan in 1973 to that in 1975?
Offer a terse response. 1.29. What is the ratio of the Exports(as % of merchandise exports) in Kiribati in 1973 to that in 1975?
Ensure brevity in your answer.  0.83. What is the ratio of the Exports(as % of merchandise exports) in Liberia in 1973 to that in 1975?
Provide a short and direct response. 1.24. What is the ratio of the Exports(as % of merchandise exports) in Paraguay in 1973 to that in 1975?
Provide a succinct answer. 1.21. What is the ratio of the Exports(as % of merchandise exports) of Jordan in 1973 to that in 1976?
Your answer should be compact. 1.22. What is the ratio of the Exports(as % of merchandise exports) in Kiribati in 1973 to that in 1976?
Offer a terse response. 0.56. What is the ratio of the Exports(as % of merchandise exports) in Liberia in 1973 to that in 1976?
Your answer should be compact. 1.77. What is the ratio of the Exports(as % of merchandise exports) of Paraguay in 1973 to that in 1976?
Your answer should be very brief. 0.96. What is the ratio of the Exports(as % of merchandise exports) of Jordan in 1973 to that in 1977?
Ensure brevity in your answer.  0.83. What is the ratio of the Exports(as % of merchandise exports) in Kiribati in 1973 to that in 1977?
Provide a succinct answer. 0.69. What is the ratio of the Exports(as % of merchandise exports) in Liberia in 1973 to that in 1977?
Give a very brief answer. 1.25. What is the ratio of the Exports(as % of merchandise exports) in Paraguay in 1973 to that in 1977?
Ensure brevity in your answer.  1.15. What is the ratio of the Exports(as % of merchandise exports) of Jordan in 1973 to that in 1978?
Give a very brief answer. 0.68. What is the ratio of the Exports(as % of merchandise exports) in Kiribati in 1973 to that in 1978?
Your answer should be compact. 2.45. What is the ratio of the Exports(as % of merchandise exports) in Liberia in 1973 to that in 1978?
Make the answer very short. 1.2. What is the ratio of the Exports(as % of merchandise exports) in Jordan in 1973 to that in 1979?
Provide a short and direct response. 0.73. What is the ratio of the Exports(as % of merchandise exports) of Kiribati in 1973 to that in 1979?
Provide a succinct answer. 4.09. What is the ratio of the Exports(as % of merchandise exports) in Liberia in 1973 to that in 1979?
Your answer should be very brief. 1.01. What is the ratio of the Exports(as % of merchandise exports) of Paraguay in 1973 to that in 1979?
Give a very brief answer. 1.12. What is the ratio of the Exports(as % of merchandise exports) in Jordan in 1973 to that in 1980?
Give a very brief answer. 0.76. What is the ratio of the Exports(as % of merchandise exports) of Kiribati in 1973 to that in 1980?
Offer a terse response. 0.92. What is the ratio of the Exports(as % of merchandise exports) in Liberia in 1973 to that in 1980?
Give a very brief answer. 0.82. What is the ratio of the Exports(as % of merchandise exports) in Paraguay in 1973 to that in 1980?
Provide a succinct answer. 1.08. What is the ratio of the Exports(as % of merchandise exports) in Jordan in 1974 to that in 1975?
Keep it short and to the point. 1.06. What is the ratio of the Exports(as % of merchandise exports) in Kiribati in 1974 to that in 1975?
Provide a short and direct response. 0.41. What is the ratio of the Exports(as % of merchandise exports) of Liberia in 1974 to that in 1975?
Give a very brief answer. 0.82. What is the ratio of the Exports(as % of merchandise exports) in Paraguay in 1974 to that in 1975?
Offer a terse response. 0.98. What is the ratio of the Exports(as % of merchandise exports) in Jordan in 1974 to that in 1976?
Ensure brevity in your answer.  1.01. What is the ratio of the Exports(as % of merchandise exports) in Kiribati in 1974 to that in 1976?
Offer a terse response. 0.28. What is the ratio of the Exports(as % of merchandise exports) in Liberia in 1974 to that in 1976?
Offer a terse response. 1.18. What is the ratio of the Exports(as % of merchandise exports) in Paraguay in 1974 to that in 1976?
Offer a very short reply. 0.77. What is the ratio of the Exports(as % of merchandise exports) of Jordan in 1974 to that in 1977?
Your answer should be compact. 0.68. What is the ratio of the Exports(as % of merchandise exports) in Kiribati in 1974 to that in 1977?
Ensure brevity in your answer.  0.34. What is the ratio of the Exports(as % of merchandise exports) in Liberia in 1974 to that in 1977?
Your answer should be very brief. 0.84. What is the ratio of the Exports(as % of merchandise exports) in Paraguay in 1974 to that in 1977?
Offer a very short reply. 0.93. What is the ratio of the Exports(as % of merchandise exports) of Jordan in 1974 to that in 1978?
Make the answer very short. 0.56. What is the ratio of the Exports(as % of merchandise exports) in Kiribati in 1974 to that in 1978?
Ensure brevity in your answer.  1.22. What is the ratio of the Exports(as % of merchandise exports) in Liberia in 1974 to that in 1978?
Keep it short and to the point. 0.8. What is the ratio of the Exports(as % of merchandise exports) in Paraguay in 1974 to that in 1978?
Give a very brief answer. 0.81. What is the ratio of the Exports(as % of merchandise exports) in Jordan in 1974 to that in 1979?
Ensure brevity in your answer.  0.6. What is the ratio of the Exports(as % of merchandise exports) in Kiribati in 1974 to that in 1979?
Your response must be concise. 2.03. What is the ratio of the Exports(as % of merchandise exports) in Liberia in 1974 to that in 1979?
Provide a succinct answer. 0.67. What is the ratio of the Exports(as % of merchandise exports) of Paraguay in 1974 to that in 1979?
Give a very brief answer. 0.9. What is the ratio of the Exports(as % of merchandise exports) of Jordan in 1974 to that in 1980?
Make the answer very short. 0.63. What is the ratio of the Exports(as % of merchandise exports) of Kiribati in 1974 to that in 1980?
Offer a terse response. 0.46. What is the ratio of the Exports(as % of merchandise exports) of Liberia in 1974 to that in 1980?
Your response must be concise. 0.55. What is the ratio of the Exports(as % of merchandise exports) in Paraguay in 1974 to that in 1980?
Provide a short and direct response. 0.87. What is the ratio of the Exports(as % of merchandise exports) of Jordan in 1975 to that in 1976?
Provide a short and direct response. 0.95. What is the ratio of the Exports(as % of merchandise exports) in Kiribati in 1975 to that in 1976?
Ensure brevity in your answer.  0.68. What is the ratio of the Exports(as % of merchandise exports) in Liberia in 1975 to that in 1976?
Offer a terse response. 1.43. What is the ratio of the Exports(as % of merchandise exports) of Paraguay in 1975 to that in 1976?
Your response must be concise. 0.79. What is the ratio of the Exports(as % of merchandise exports) in Jordan in 1975 to that in 1977?
Provide a succinct answer. 0.64. What is the ratio of the Exports(as % of merchandise exports) of Kiribati in 1975 to that in 1977?
Your answer should be very brief. 0.83. What is the ratio of the Exports(as % of merchandise exports) in Liberia in 1975 to that in 1977?
Provide a succinct answer. 1.01. What is the ratio of the Exports(as % of merchandise exports) in Jordan in 1975 to that in 1978?
Offer a terse response. 0.52. What is the ratio of the Exports(as % of merchandise exports) in Kiribati in 1975 to that in 1978?
Your answer should be very brief. 2.96. What is the ratio of the Exports(as % of merchandise exports) in Liberia in 1975 to that in 1978?
Provide a short and direct response. 0.97. What is the ratio of the Exports(as % of merchandise exports) of Paraguay in 1975 to that in 1978?
Offer a terse response. 0.83. What is the ratio of the Exports(as % of merchandise exports) in Jordan in 1975 to that in 1979?
Offer a terse response. 0.56. What is the ratio of the Exports(as % of merchandise exports) of Kiribati in 1975 to that in 1979?
Offer a very short reply. 4.95. What is the ratio of the Exports(as % of merchandise exports) in Liberia in 1975 to that in 1979?
Ensure brevity in your answer.  0.81. What is the ratio of the Exports(as % of merchandise exports) in Paraguay in 1975 to that in 1979?
Provide a short and direct response. 0.92. What is the ratio of the Exports(as % of merchandise exports) in Jordan in 1975 to that in 1980?
Provide a succinct answer. 0.59. What is the ratio of the Exports(as % of merchandise exports) of Kiribati in 1975 to that in 1980?
Provide a succinct answer. 1.11. What is the ratio of the Exports(as % of merchandise exports) of Liberia in 1975 to that in 1980?
Your answer should be compact. 0.66. What is the ratio of the Exports(as % of merchandise exports) in Paraguay in 1975 to that in 1980?
Provide a short and direct response. 0.89. What is the ratio of the Exports(as % of merchandise exports) in Jordan in 1976 to that in 1977?
Provide a succinct answer. 0.67. What is the ratio of the Exports(as % of merchandise exports) in Kiribati in 1976 to that in 1977?
Provide a short and direct response. 1.22. What is the ratio of the Exports(as % of merchandise exports) in Liberia in 1976 to that in 1977?
Offer a very short reply. 0.71. What is the ratio of the Exports(as % of merchandise exports) in Paraguay in 1976 to that in 1977?
Your answer should be very brief. 1.2. What is the ratio of the Exports(as % of merchandise exports) of Jordan in 1976 to that in 1978?
Offer a very short reply. 0.55. What is the ratio of the Exports(as % of merchandise exports) in Kiribati in 1976 to that in 1978?
Keep it short and to the point. 4.35. What is the ratio of the Exports(as % of merchandise exports) in Liberia in 1976 to that in 1978?
Offer a terse response. 0.68. What is the ratio of the Exports(as % of merchandise exports) in Paraguay in 1976 to that in 1978?
Keep it short and to the point. 1.04. What is the ratio of the Exports(as % of merchandise exports) in Jordan in 1976 to that in 1979?
Provide a succinct answer. 0.59. What is the ratio of the Exports(as % of merchandise exports) in Kiribati in 1976 to that in 1979?
Provide a short and direct response. 7.27. What is the ratio of the Exports(as % of merchandise exports) in Liberia in 1976 to that in 1979?
Make the answer very short. 0.57. What is the ratio of the Exports(as % of merchandise exports) in Paraguay in 1976 to that in 1979?
Your response must be concise. 1.17. What is the ratio of the Exports(as % of merchandise exports) in Jordan in 1976 to that in 1980?
Provide a succinct answer. 0.62. What is the ratio of the Exports(as % of merchandise exports) in Kiribati in 1976 to that in 1980?
Your answer should be very brief. 1.63. What is the ratio of the Exports(as % of merchandise exports) of Liberia in 1976 to that in 1980?
Offer a terse response. 0.46. What is the ratio of the Exports(as % of merchandise exports) of Paraguay in 1976 to that in 1980?
Provide a short and direct response. 1.12. What is the ratio of the Exports(as % of merchandise exports) of Jordan in 1977 to that in 1978?
Your response must be concise. 0.82. What is the ratio of the Exports(as % of merchandise exports) in Kiribati in 1977 to that in 1978?
Your response must be concise. 3.56. What is the ratio of the Exports(as % of merchandise exports) of Liberia in 1977 to that in 1978?
Provide a succinct answer. 0.96. What is the ratio of the Exports(as % of merchandise exports) in Paraguay in 1977 to that in 1978?
Give a very brief answer. 0.87. What is the ratio of the Exports(as % of merchandise exports) of Jordan in 1977 to that in 1979?
Offer a very short reply. 0.88. What is the ratio of the Exports(as % of merchandise exports) in Kiribati in 1977 to that in 1979?
Offer a terse response. 5.95. What is the ratio of the Exports(as % of merchandise exports) of Liberia in 1977 to that in 1979?
Offer a terse response. 0.8. What is the ratio of the Exports(as % of merchandise exports) in Paraguay in 1977 to that in 1979?
Offer a very short reply. 0.97. What is the ratio of the Exports(as % of merchandise exports) of Jordan in 1977 to that in 1980?
Make the answer very short. 0.92. What is the ratio of the Exports(as % of merchandise exports) of Kiribati in 1977 to that in 1980?
Offer a terse response. 1.33. What is the ratio of the Exports(as % of merchandise exports) in Liberia in 1977 to that in 1980?
Provide a succinct answer. 0.65. What is the ratio of the Exports(as % of merchandise exports) in Paraguay in 1977 to that in 1980?
Provide a short and direct response. 0.93. What is the ratio of the Exports(as % of merchandise exports) of Jordan in 1978 to that in 1979?
Offer a terse response. 1.07. What is the ratio of the Exports(as % of merchandise exports) in Kiribati in 1978 to that in 1979?
Your response must be concise. 1.67. What is the ratio of the Exports(as % of merchandise exports) of Liberia in 1978 to that in 1979?
Offer a terse response. 0.84. What is the ratio of the Exports(as % of merchandise exports) in Paraguay in 1978 to that in 1979?
Your answer should be very brief. 1.12. What is the ratio of the Exports(as % of merchandise exports) in Jordan in 1978 to that in 1980?
Provide a succinct answer. 1.13. What is the ratio of the Exports(as % of merchandise exports) in Kiribati in 1978 to that in 1980?
Your answer should be very brief. 0.37. What is the ratio of the Exports(as % of merchandise exports) in Liberia in 1978 to that in 1980?
Offer a very short reply. 0.68. What is the ratio of the Exports(as % of merchandise exports) in Paraguay in 1978 to that in 1980?
Make the answer very short. 1.07. What is the ratio of the Exports(as % of merchandise exports) in Jordan in 1979 to that in 1980?
Make the answer very short. 1.05. What is the ratio of the Exports(as % of merchandise exports) of Kiribati in 1979 to that in 1980?
Make the answer very short. 0.22. What is the ratio of the Exports(as % of merchandise exports) in Liberia in 1979 to that in 1980?
Provide a succinct answer. 0.82. What is the ratio of the Exports(as % of merchandise exports) of Paraguay in 1979 to that in 1980?
Your answer should be compact. 0.96. What is the difference between the highest and the second highest Exports(as % of merchandise exports) in Jordan?
Provide a succinct answer. 2.59. What is the difference between the highest and the second highest Exports(as % of merchandise exports) in Kiribati?
Your response must be concise. 0.04. What is the difference between the highest and the second highest Exports(as % of merchandise exports) of Liberia?
Provide a succinct answer. 0.33. What is the difference between the highest and the second highest Exports(as % of merchandise exports) of Paraguay?
Make the answer very short. 0.55. What is the difference between the highest and the lowest Exports(as % of merchandise exports) of Jordan?
Offer a terse response. 18.11. What is the difference between the highest and the lowest Exports(as % of merchandise exports) in Kiribati?
Your answer should be very brief. 0.17. What is the difference between the highest and the lowest Exports(as % of merchandise exports) of Liberia?
Provide a short and direct response. 1. What is the difference between the highest and the lowest Exports(as % of merchandise exports) in Paraguay?
Give a very brief answer. 2.99. 